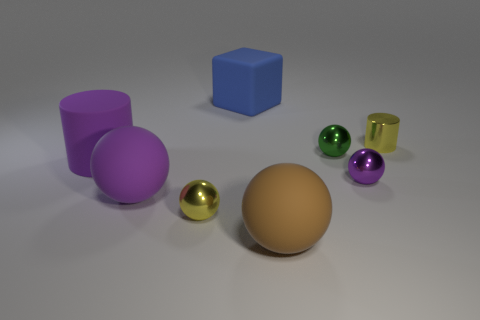There is a object that is the same color as the metal cylinder; what is its material?
Your answer should be compact. Metal. What number of other objects are there of the same color as the big cylinder?
Your response must be concise. 2. There is a large rubber ball that is behind the small thing on the left side of the big sphere that is on the right side of the big blue thing; what is its color?
Your answer should be very brief. Purple. Are there the same number of tiny purple shiny balls that are to the right of the purple metallic sphere and small purple rubber objects?
Your response must be concise. Yes. There is a yellow sphere on the left side of the blue rubber cube; is it the same size as the brown rubber ball?
Your answer should be very brief. No. What number of rubber objects are there?
Provide a short and direct response. 4. What number of large matte things are right of the large rubber cylinder and in front of the yellow metal cylinder?
Offer a terse response. 2. Are there any large purple things made of the same material as the brown object?
Your answer should be very brief. Yes. What material is the tiny yellow object on the right side of the big matte object behind the small yellow cylinder?
Provide a short and direct response. Metal. Are there an equal number of yellow balls behind the big cylinder and large rubber spheres behind the tiny green shiny ball?
Make the answer very short. Yes. 